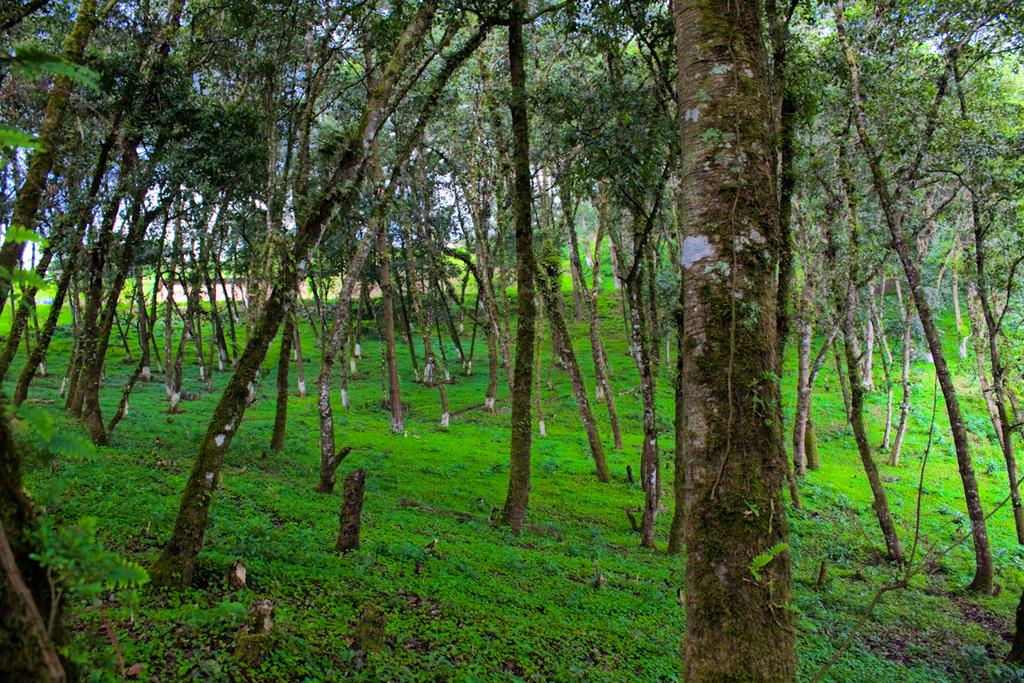What type of vegetation is present in the image? There are many trees in the image. What is the ground surface like where the trees are located? The trees are on a grassy land. What can be seen in the background of the image? The sky is visible in the background of the image. What is the value of the mine in the image? There is no mine present in the image, so it is not possible to determine its value. 